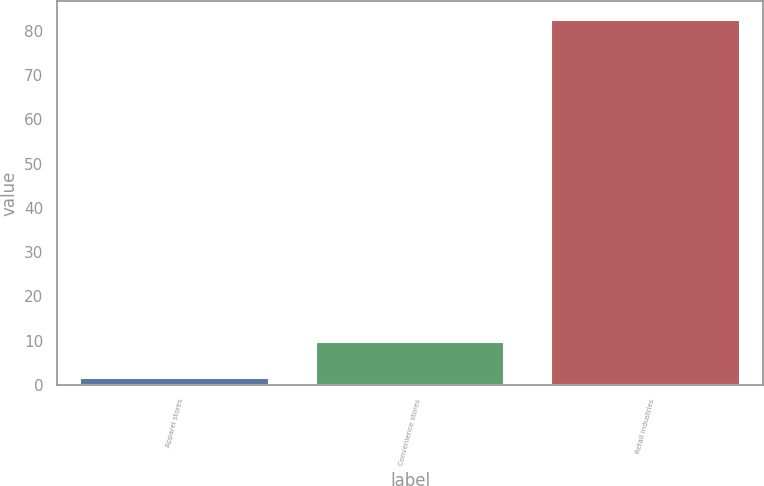<chart> <loc_0><loc_0><loc_500><loc_500><bar_chart><fcel>Apparel stores<fcel>Convenience stores<fcel>Retail industries<nl><fcel>1.6<fcel>9.69<fcel>82.5<nl></chart> 